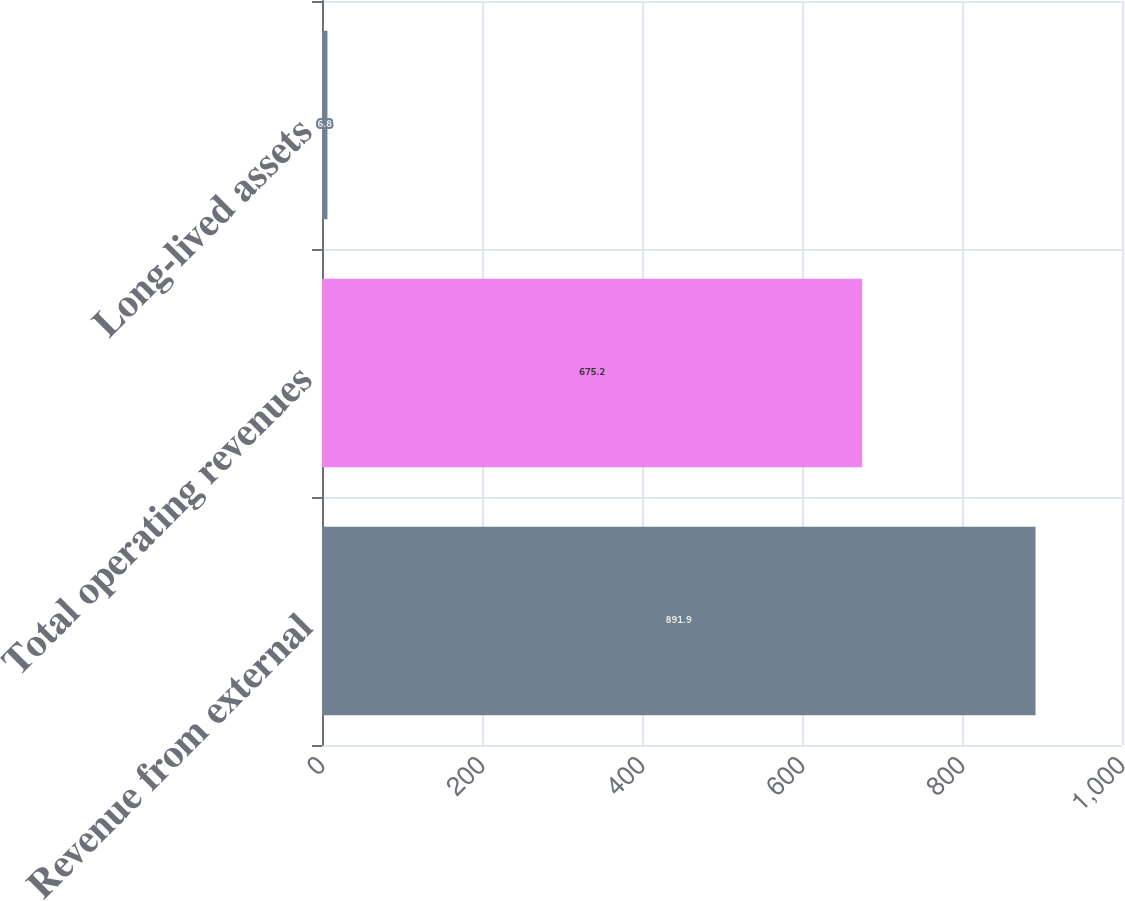Convert chart. <chart><loc_0><loc_0><loc_500><loc_500><bar_chart><fcel>Revenue from external<fcel>Total operating revenues<fcel>Long-lived assets<nl><fcel>891.9<fcel>675.2<fcel>6.8<nl></chart> 